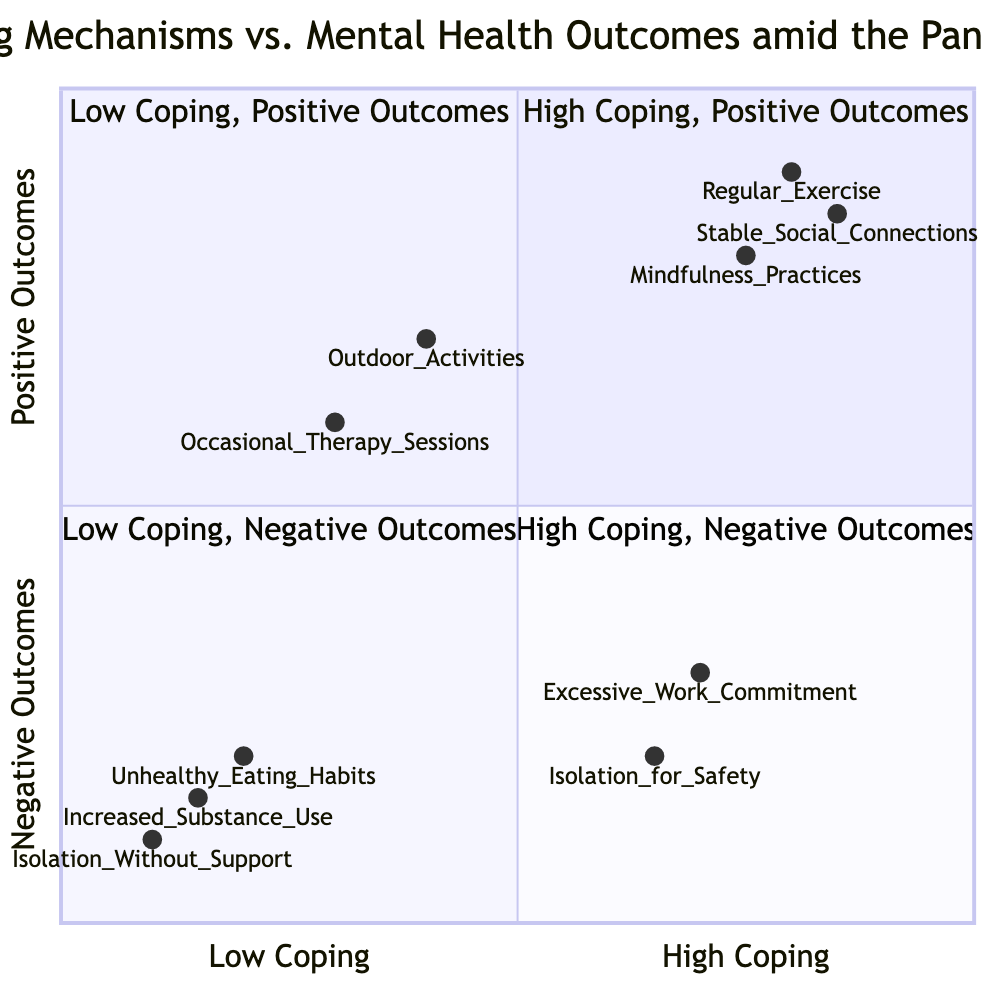What is the total number of coping mechanisms listed? The diagram lists a total of nine coping mechanisms across the four quadrants. Counting each element: three from "High Coping, Positive Outcomes", two from "High Coping, Negative Outcomes", two from "Low Coping, Positive Outcomes", and three from "Low Coping, Negative Outcomes" results in a total of nine.
Answer: 9 Which coping mechanism is associated with the lowest coping level? The element "Isolation Without Support" is located in the "Low Coping, Negative Outcomes" quadrant, and based on its coordinates [0.1, 0.1], it shows the lowest level of coping among all mechanisms in the chart.
Answer: Isolation Without Support How many coping mechanisms have positive mental health outcomes? There are five coping mechanisms that have positive mental health outcomes, as they are located in the "High Coping, Positive Outcomes" and "Low Coping, Positive Outcomes" quadrants.
Answer: 5 What is the y-value of "Excessive Work Commitment"? The y-value represents the mental health outcomes and for "Excessive Work Commitment", the coordinate is [0.7, 0.3], making the y-value 0.3. This indicates a negative mental health outcome associated with that coping mechanism.
Answer: 0.3 Which coping mechanism has the highest coping score? "Stable Social Connections" has the highest coping score with coordinates [0.85, 0.85], representing its efficacy in both coping and positive mental health outcomes.
Answer: Stable Social Connections What is the x-value of "Outdoor Activities"? The x-value is related to the coping level of "Outdoor Activities", which is shown as [0.4, 0.7]. Thus, the x-value indicates it has a moderate level of coping at 0.4.
Answer: 0.4 Which quadrant has coping mechanisms that lead to negative outcomes despite being high coping strategies? The quadrant "High Coping, Negative Outcomes" contains coping mechanisms that lead to negative outcomes. It includes "Excessive Work Commitment" and "Isolation for Safety".
Answer: High Coping, Negative Outcomes Which coping mechanism has a positive outcome but low coping effort? "Occasional Therapy Sessions" is categorized under "Low Coping, Positive Outcomes", suggesting it has a mild coping effort but still results in a positive outcome.
Answer: Occasional Therapy Sessions 